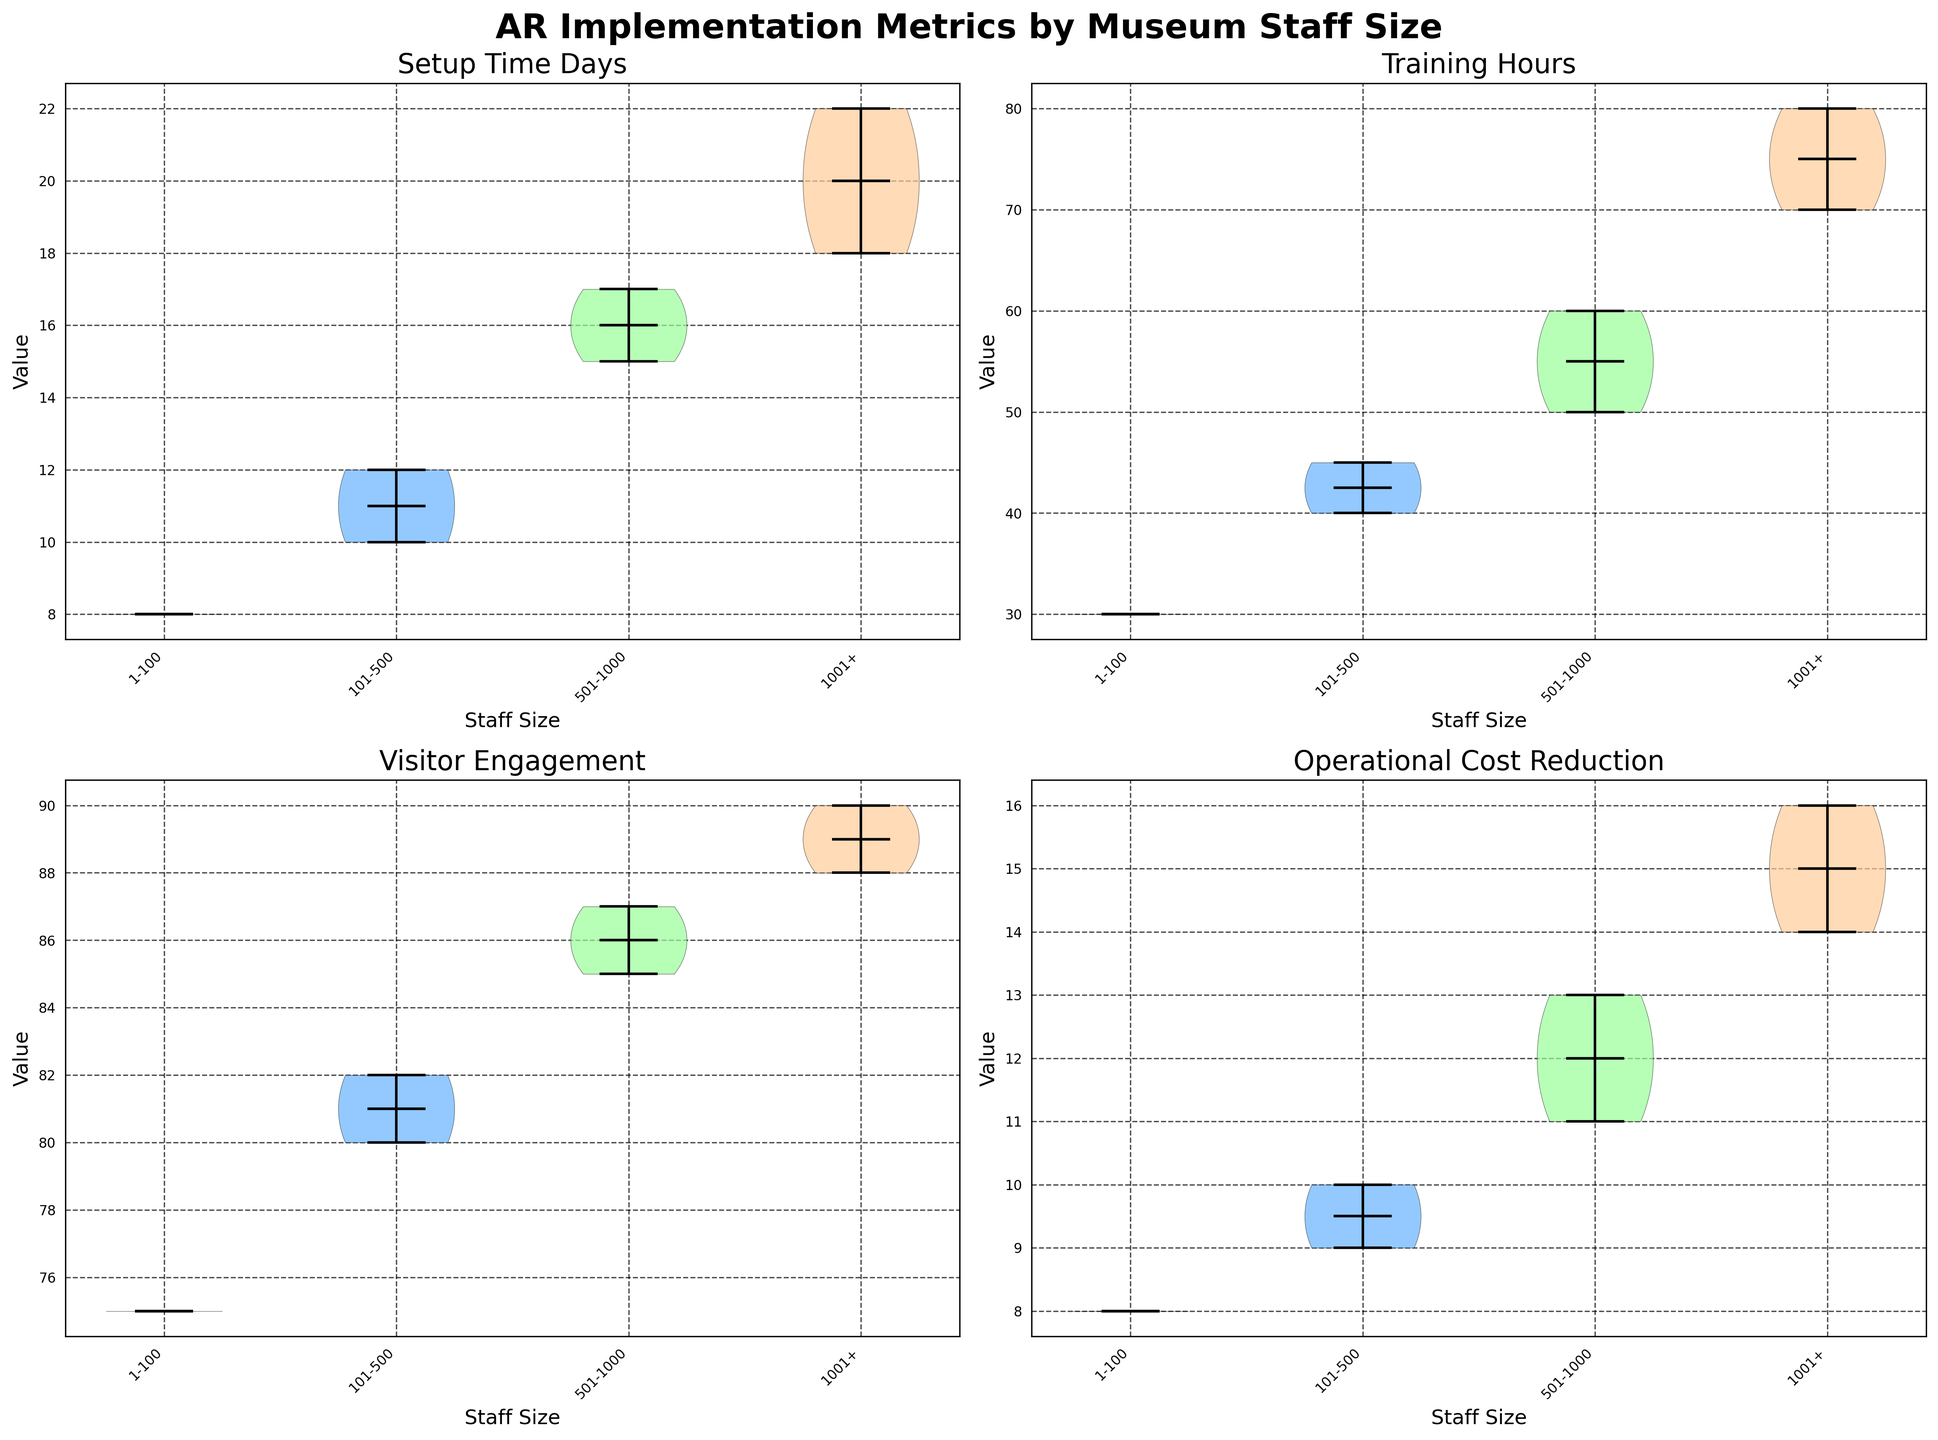What is the median setup time for museums with staff sizes of 101-500? Look at the violin plot for "Setup Time Days" and find the violin corresponding to staff size "101-500". The median is indicated by the horizontal line inside the violin shape.
Answer: 11 days Which staff size category has the highest average visitor engagement? Check the "Visitor Engagement" violin plots for each staff size category. The average is typically indicated by a dot in the middle of the violins. The "1001+" category has the highest average dot position.
Answer: 1001+ How many visitor engagement metrics are plotted for museums with staff sizes of 501-1000? Look at the "Visitor Engagement" violin for the staff size "501-1000" and count the number of individual data points visible in the plot.
Answer: 3 data points Which staff size category shows the lowest median operational cost reduction? Observe the "Operational Cost Reduction" violin plots and identify the one with the lowest horizontal median line within the violins. The staff size "1-100" has the lowest median.
Answer: 1-100 What is the average training hours for museums with staff sizes of 501-1000 and 1001+? Determine the average values from the violin plots for "Training Hours" in both "501-1000" and "1001+" staff size categories. The averages are shown by the dots. Add these dots' positions together and divide by 2.
Answer: (55+75)/2 = 65 hours Which metric shows the smallest variability for museums with staff sizes of 1-100? Review all the violin plots for the "1-100" staff size category and compare the spread of the values. The "Operational Cost Reduction" has the narrowest spread.
Answer: Operational Cost Reduction Is the median setup time higher for museums with staff sizes of 501-1000 or 1001+? Compare the medians shown as horizontal lines in the "Setup Time Days" violins for "501-1000" and "1001+" categories. The "1001+" category has a higher median.
Answer: 1001+ How does the median visitor engagement compare between museums with staff sizes of 101-500 and 501-1000? Check the median positions in the "Visitor Engagement" violins for "101-500" and "501-1000". Compare these two values. The median for "501-1000" is higher.
Answer: 501-1000 has higher median How does the maximum setup time compare between the 101-500 and 501-1000 staff size categories? Identify the maximum values in the "Setup Time Days" violins for "101-500" and "501-1000". Compare these two maximum points. The "501-1000" category has a higher maximum.
Answer: 501-1000 has higher maximum Which staff size category shows the most variance in training hours? Evaluate the spreads of the violins in "Training Hours" for each staff size category. The "1001+" category has the widest spread, indicating the most variance.
Answer: 1001+ 